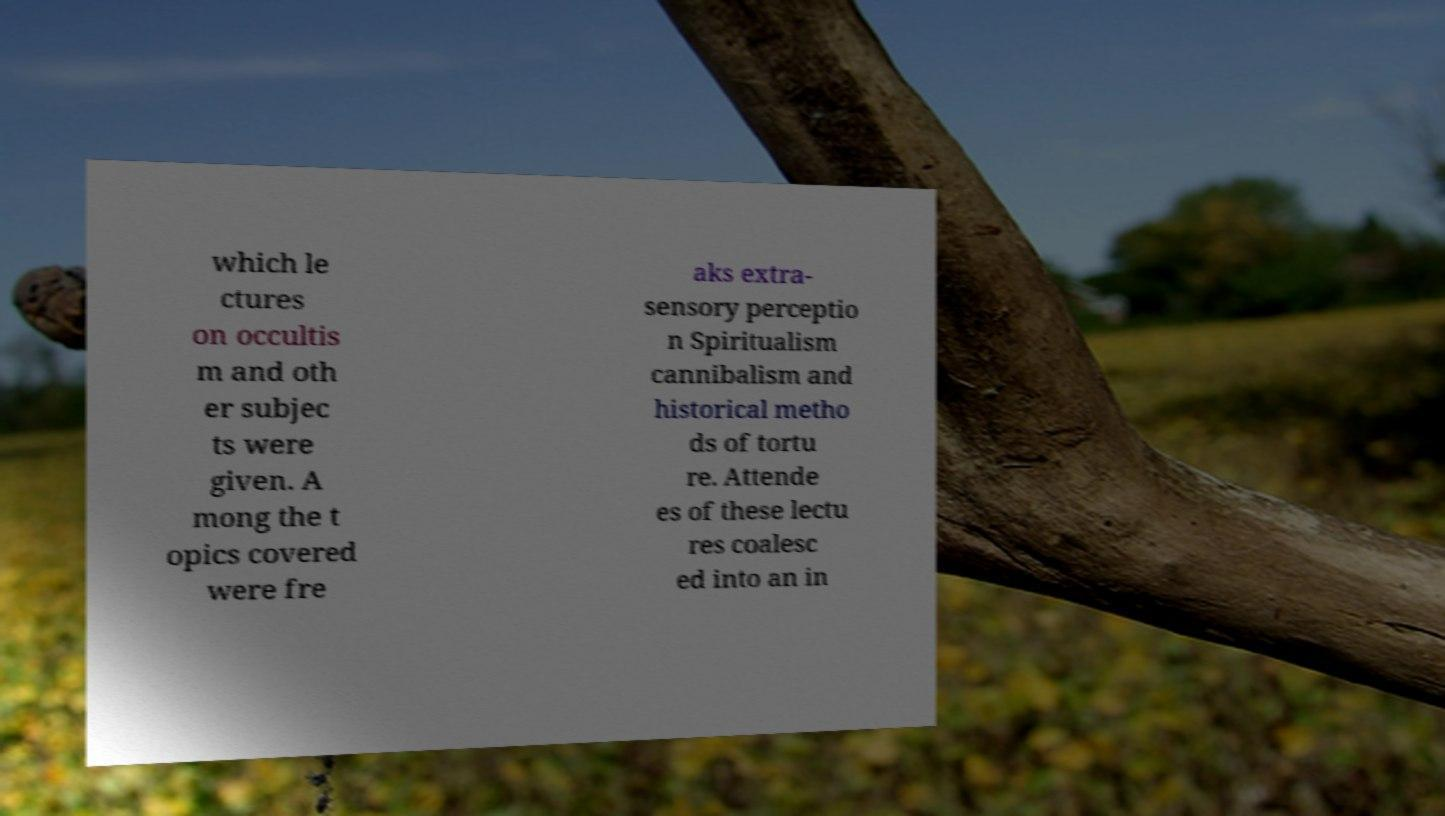I need the written content from this picture converted into text. Can you do that? which le ctures on occultis m and oth er subjec ts were given. A mong the t opics covered were fre aks extra- sensory perceptio n Spiritualism cannibalism and historical metho ds of tortu re. Attende es of these lectu res coalesc ed into an in 